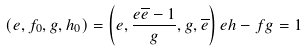<formula> <loc_0><loc_0><loc_500><loc_500>( e , f _ { 0 } , g , h _ { 0 } ) = \left ( e , \frac { e \overline { e } - 1 } { g } , g , \overline { e } \right ) e h - f g = 1</formula> 